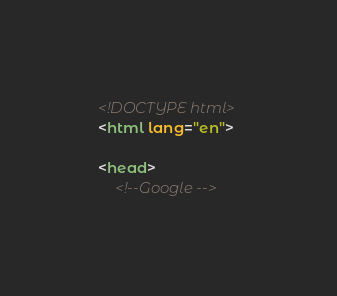<code> <loc_0><loc_0><loc_500><loc_500><_HTML_><!DOCTYPE html>
<html lang="en">

<head>
    <!--Google --></code> 